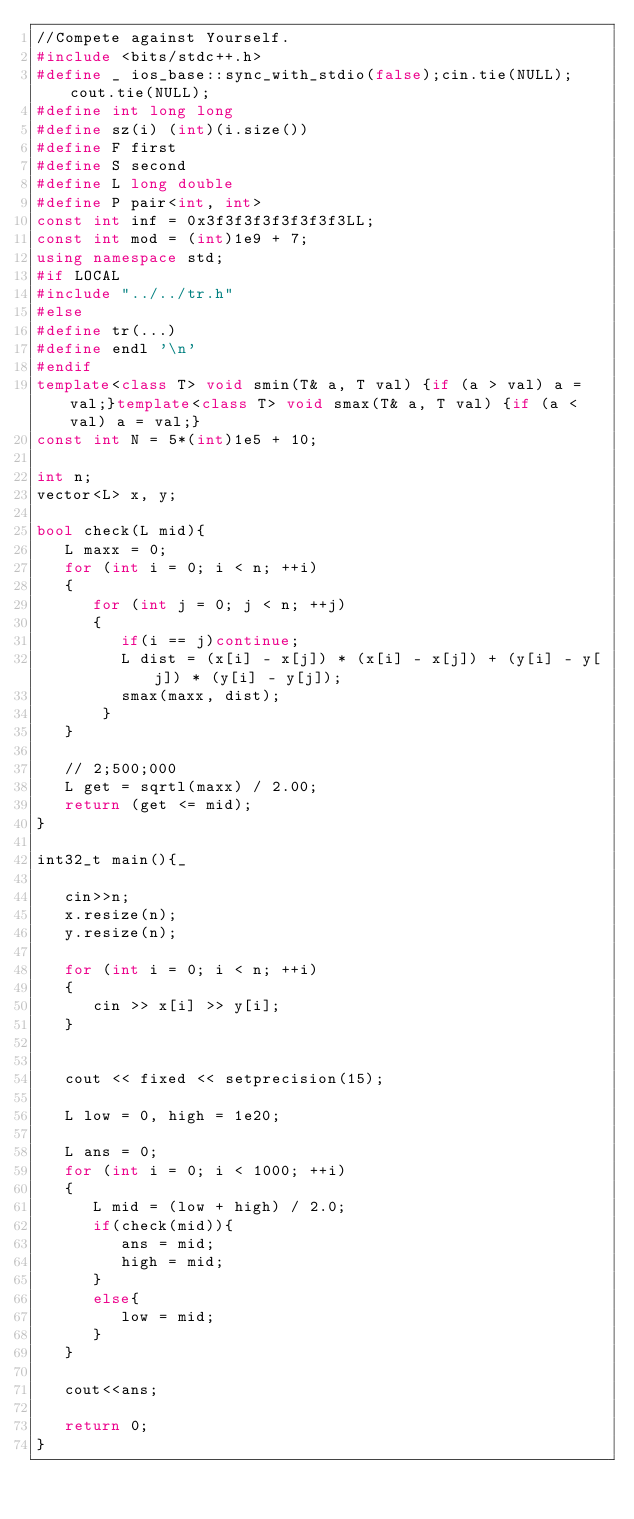<code> <loc_0><loc_0><loc_500><loc_500><_C++_>//Compete against Yourself.
#include <bits/stdc++.h>
#define _ ios_base::sync_with_stdio(false);cin.tie(NULL);cout.tie(NULL);
#define int long long
#define sz(i) (int)(i.size())
#define F first
#define S second
#define L long double
#define P pair<int, int>
const int inf = 0x3f3f3f3f3f3f3f3LL;
const int mod = (int)1e9 + 7;
using namespace std;
#if LOCAL
#include "../../tr.h"
#else
#define tr(...)
#define endl '\n'
#endif
template<class T> void smin(T& a, T val) {if (a > val) a = val;}template<class T> void smax(T& a, T val) {if (a < val) a = val;}
const int N = 5*(int)1e5 + 10;

int n;
vector<L> x, y;

bool check(L mid){
   L maxx = 0;
   for (int i = 0; i < n; ++i)
   {
      for (int j = 0; j < n; ++j)
      {
         if(i == j)continue;
         L dist = (x[i] - x[j]) * (x[i] - x[j]) + (y[i] - y[j]) * (y[i] - y[j]);
         smax(maxx, dist);
       }
   }

   // 2;500;000
   L get = sqrtl(maxx) / 2.00;
   return (get <= mid);
}

int32_t main(){_
   
   cin>>n;
   x.resize(n);
   y.resize(n);

   for (int i = 0; i < n; ++i)
   {
      cin >> x[i] >> y[i];
   }


   cout << fixed << setprecision(15);

   L low = 0, high = 1e20;

   L ans = 0;
   for (int i = 0; i < 1000; ++i)
   {
      L mid = (low + high) / 2.0;
      if(check(mid)){
         ans = mid;
         high = mid;
      }
      else{
         low = mid;
      }
   }   

   cout<<ans;

   return 0;
}</code> 